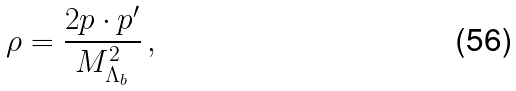Convert formula to latex. <formula><loc_0><loc_0><loc_500><loc_500>\rho = \frac { 2 p \cdot p ^ { \prime } } { M _ { \Lambda _ { b } } ^ { 2 } } \, ,</formula> 